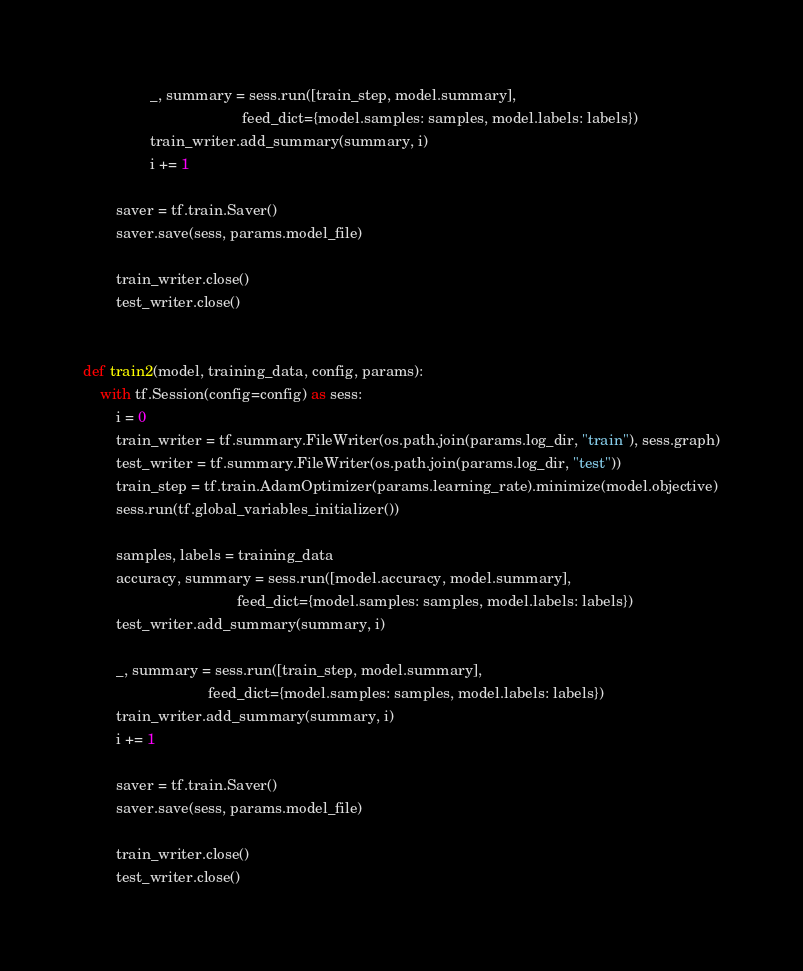Convert code to text. <code><loc_0><loc_0><loc_500><loc_500><_Python_>                _, summary = sess.run([train_step, model.summary],
                                      feed_dict={model.samples: samples, model.labels: labels})
                train_writer.add_summary(summary, i)
                i += 1

        saver = tf.train.Saver()
        saver.save(sess, params.model_file)

        train_writer.close()
        test_writer.close()


def train2(model, training_data, config, params):
    with tf.Session(config=config) as sess:
        i = 0
        train_writer = tf.summary.FileWriter(os.path.join(params.log_dir, "train"), sess.graph)
        test_writer = tf.summary.FileWriter(os.path.join(params.log_dir, "test"))
        train_step = tf.train.AdamOptimizer(params.learning_rate).minimize(model.objective)
        sess.run(tf.global_variables_initializer())

        samples, labels = training_data
        accuracy, summary = sess.run([model.accuracy, model.summary],
                                     feed_dict={model.samples: samples, model.labels: labels})
        test_writer.add_summary(summary, i)

        _, summary = sess.run([train_step, model.summary],
                              feed_dict={model.samples: samples, model.labels: labels})
        train_writer.add_summary(summary, i)
        i += 1

        saver = tf.train.Saver()
        saver.save(sess, params.model_file)

        train_writer.close()
        test_writer.close()
</code> 